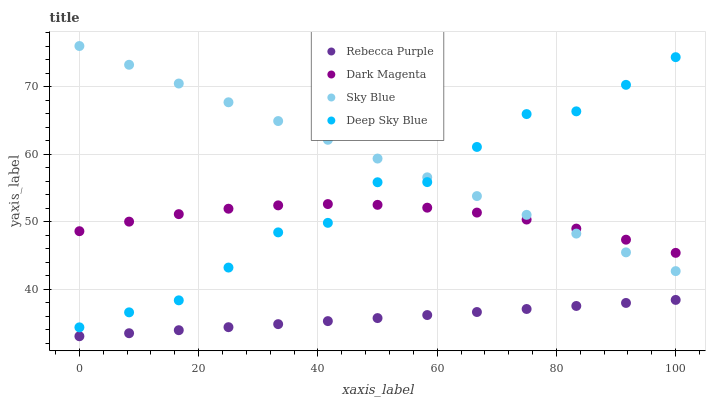Does Rebecca Purple have the minimum area under the curve?
Answer yes or no. Yes. Does Sky Blue have the maximum area under the curve?
Answer yes or no. Yes. Does Deep Sky Blue have the minimum area under the curve?
Answer yes or no. No. Does Deep Sky Blue have the maximum area under the curve?
Answer yes or no. No. Is Sky Blue the smoothest?
Answer yes or no. Yes. Is Deep Sky Blue the roughest?
Answer yes or no. Yes. Is Rebecca Purple the smoothest?
Answer yes or no. No. Is Rebecca Purple the roughest?
Answer yes or no. No. Does Rebecca Purple have the lowest value?
Answer yes or no. Yes. Does Deep Sky Blue have the lowest value?
Answer yes or no. No. Does Sky Blue have the highest value?
Answer yes or no. Yes. Does Deep Sky Blue have the highest value?
Answer yes or no. No. Is Rebecca Purple less than Dark Magenta?
Answer yes or no. Yes. Is Deep Sky Blue greater than Rebecca Purple?
Answer yes or no. Yes. Does Deep Sky Blue intersect Sky Blue?
Answer yes or no. Yes. Is Deep Sky Blue less than Sky Blue?
Answer yes or no. No. Is Deep Sky Blue greater than Sky Blue?
Answer yes or no. No. Does Rebecca Purple intersect Dark Magenta?
Answer yes or no. No. 